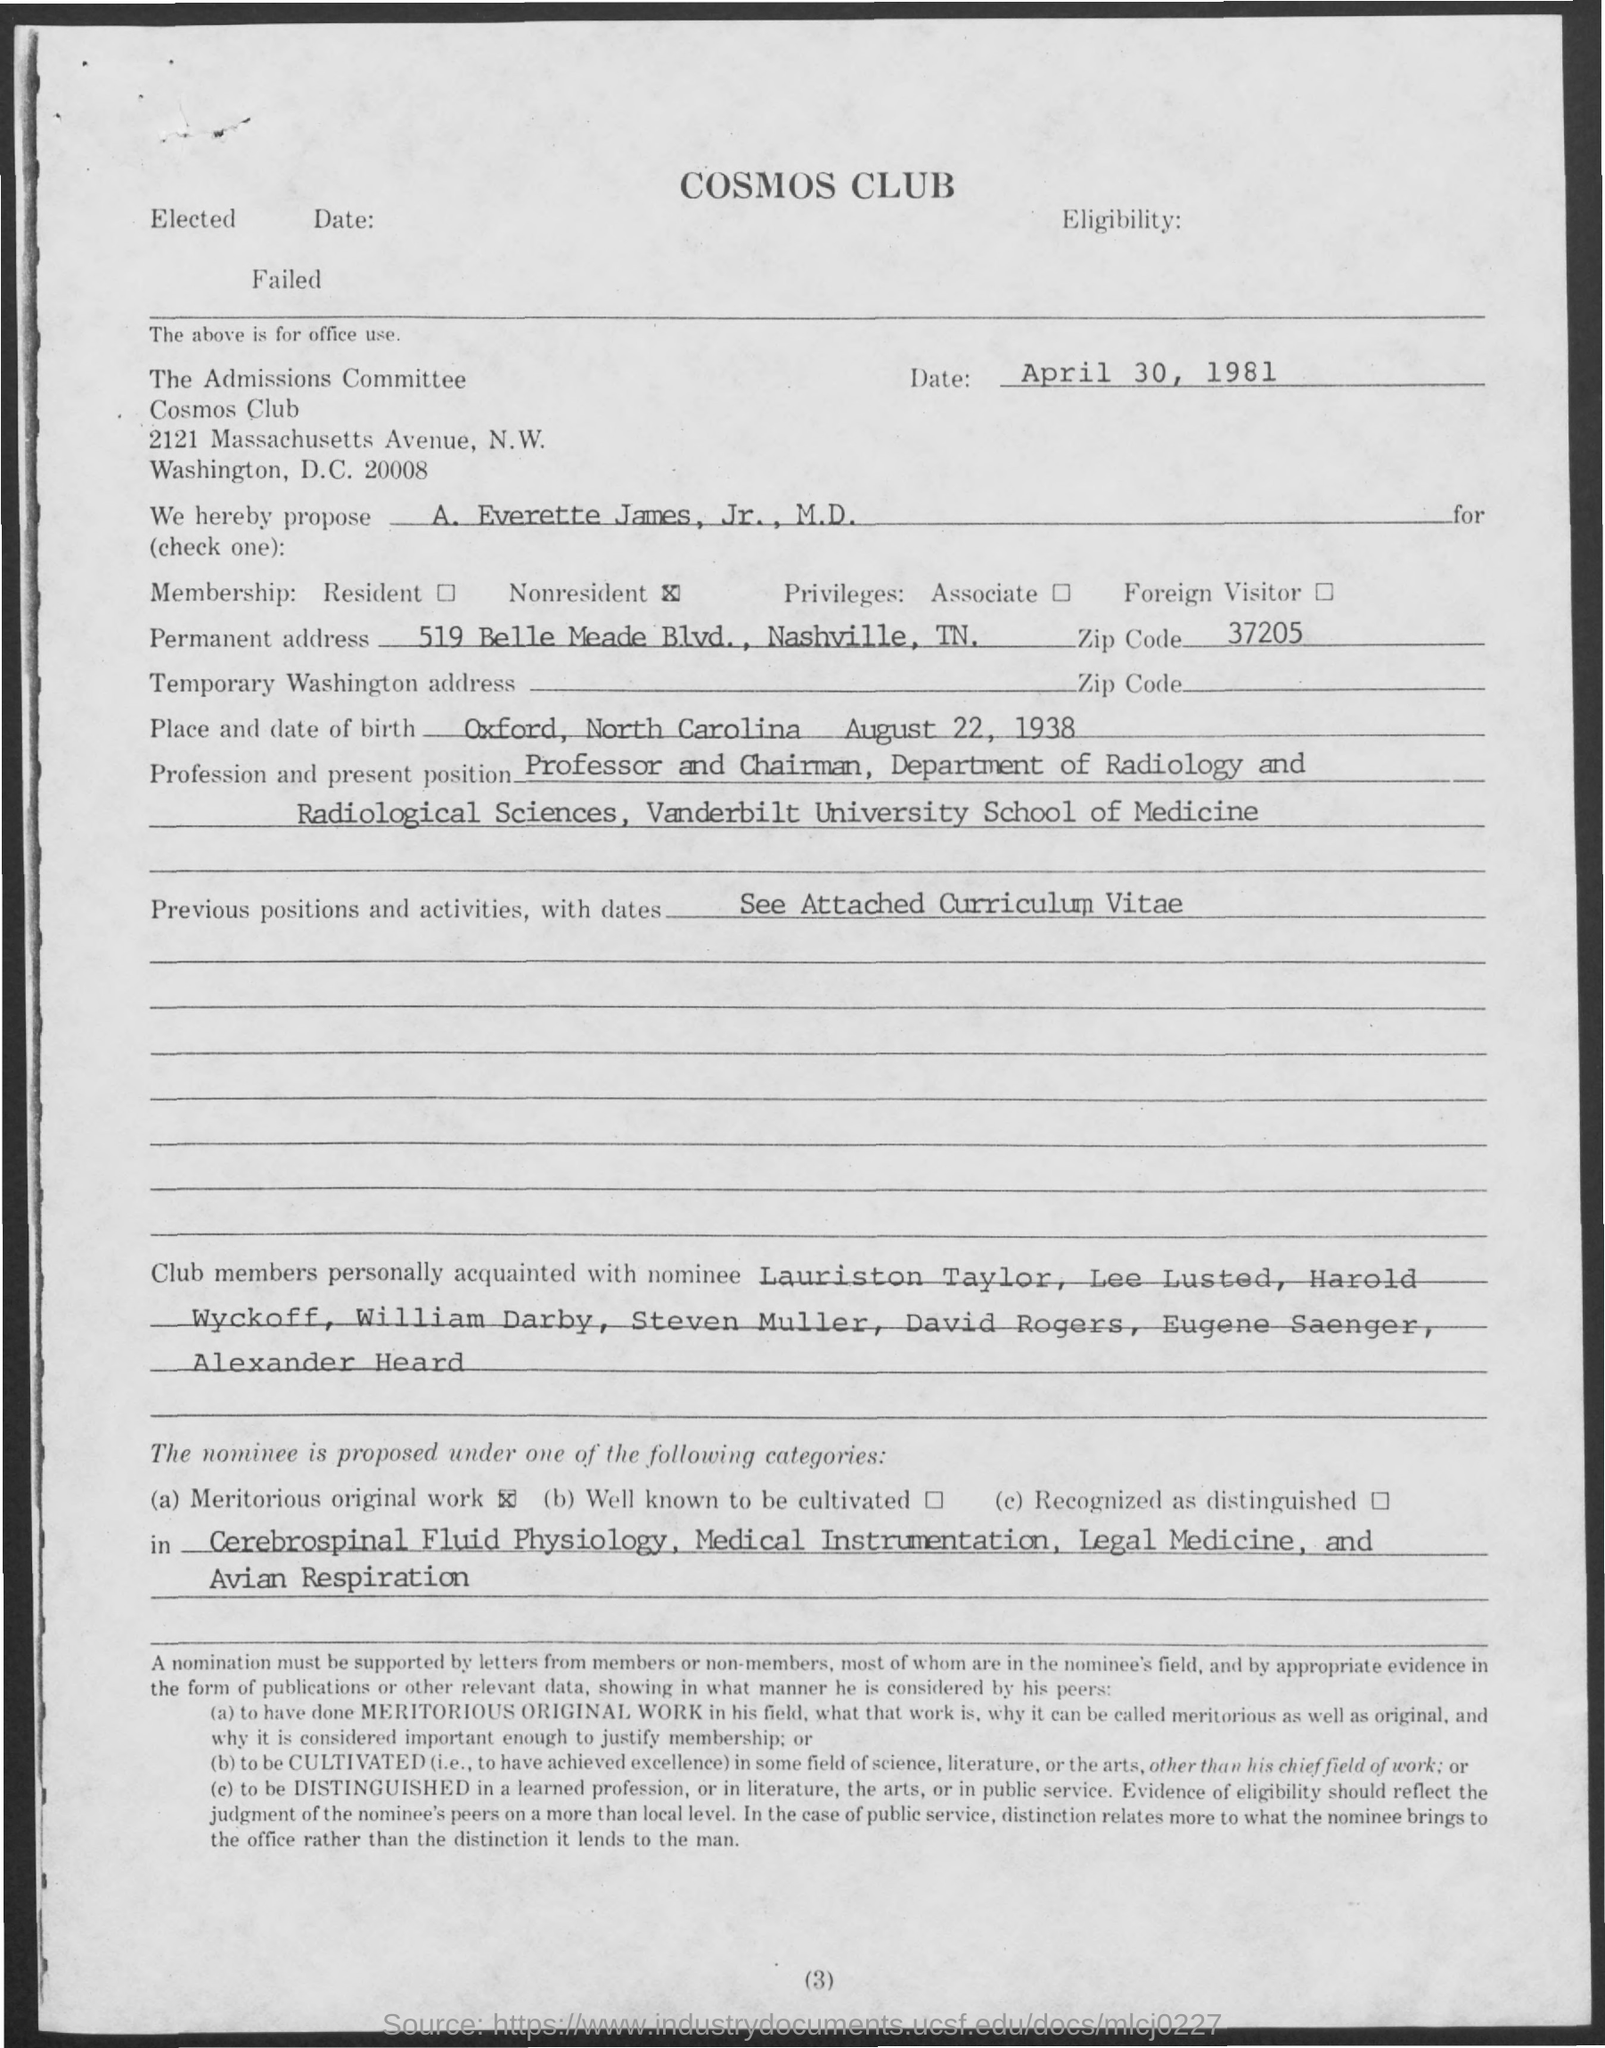What is the Title of the document?
Offer a very short reply. Cosmos club. What is the place of birth?
Provide a short and direct response. Oxford, north carolina. What is the date of birth?
Your answer should be very brief. August 22, 1938. What is the Permanent address?
Your answer should be compact. 519 Belle Meade Blvd, Nashville, TN. 